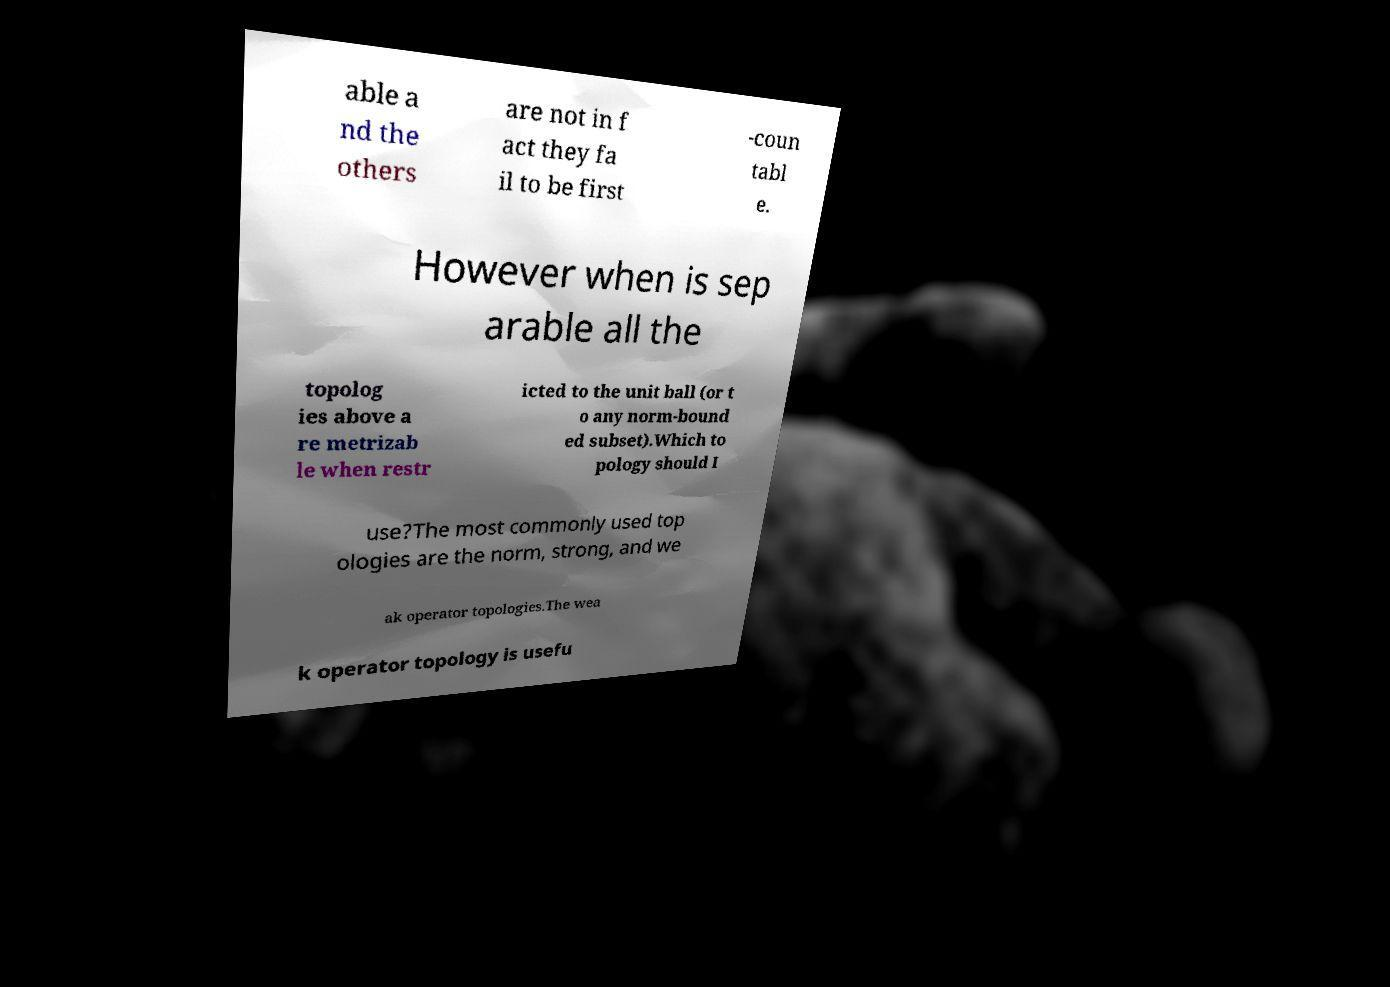Could you extract and type out the text from this image? able a nd the others are not in f act they fa il to be first -coun tabl e. However when is sep arable all the topolog ies above a re metrizab le when restr icted to the unit ball (or t o any norm-bound ed subset).Which to pology should I use?The most commonly used top ologies are the norm, strong, and we ak operator topologies.The wea k operator topology is usefu 